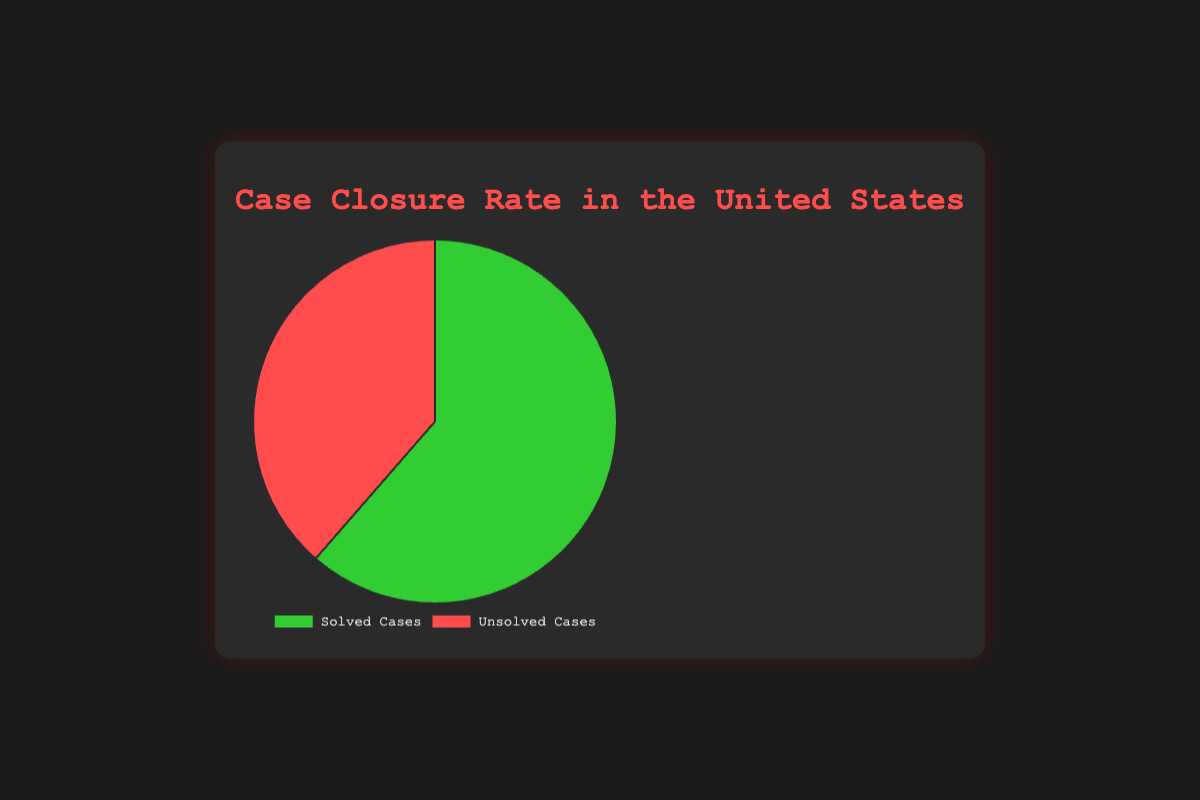What percentage of cases are solved in the United States? The pie chart shows the distribution between solved and unsolved cases. The segment labeled "Solved Cases" shows a percentage of 61.4%.
Answer: 61.4% Which type of case, solved or unsolved, has a greater percentage? The pie chart has two segments representing solved and unsolved cases. The solved cases segment is larger with 61.4% compared to 38.6% for unsolved cases.
Answer: Solved cases By how much percentage do solved cases exceed unsolved cases? Subtract the percentage of unsolved cases (38.6%) from solved cases (61.4%): 61.4% - 38.6% = 22.8%.
Answer: 22.8% What is the combined percentage of solved and unsolved cases? Sum the percentages of solved cases (61.4%) and unsolved cases (38.6%): 61.4% + 38.6% = 100%.
Answer: 100% What color represents unsolved cases in the pie chart? The visual representation of the pie chart shows that the unsolved cases segment is colored red.
Answer: Red If there are 1,000 cases in total, how many cases are solved? To find the number of solved cases, multiply the total number of cases (1,000) by the percentage of solved cases (61.4%): 1,000 x 0.614 = 614 cases.
Answer: 614 What fraction of the pie chart consists of unsolved cases? The unsolved cases make up 38.6%, which can be represented as the fraction 38.6/100 or simplified to 193/500.
Answer: 193/500 Are there more solved or unsolved cases, and by what color is that category represented? The pie chart shows more solved cases, which is 61.4%. This segment is represented by the color green.
Answer: Solved cases, green 